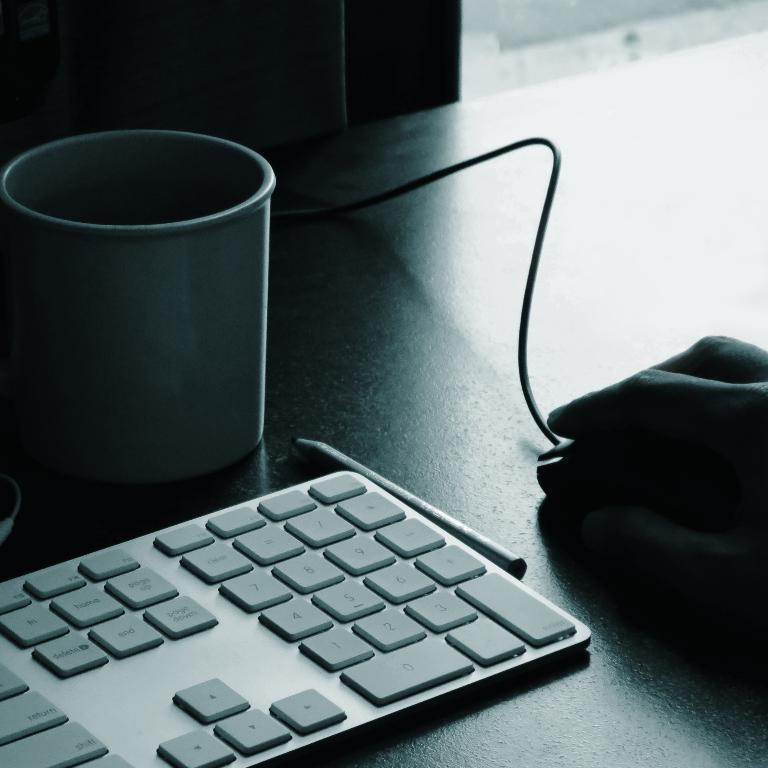What is the person's hand touching in the image? The person's hand is on the mouse in the image. What object is visible in the image that is commonly used for writing? There is a pencil in the image. What device is present in the image that is used for typing? There is a keyboard in the image. What object is present in the image that might be used for holding a beverage? There is a cup in the image. What type of cushion is present in the image? There is no cushion present in the image. What is the mass of the pencil in the image? It is not possible to determine the mass of the pencil in the image without additional information. 